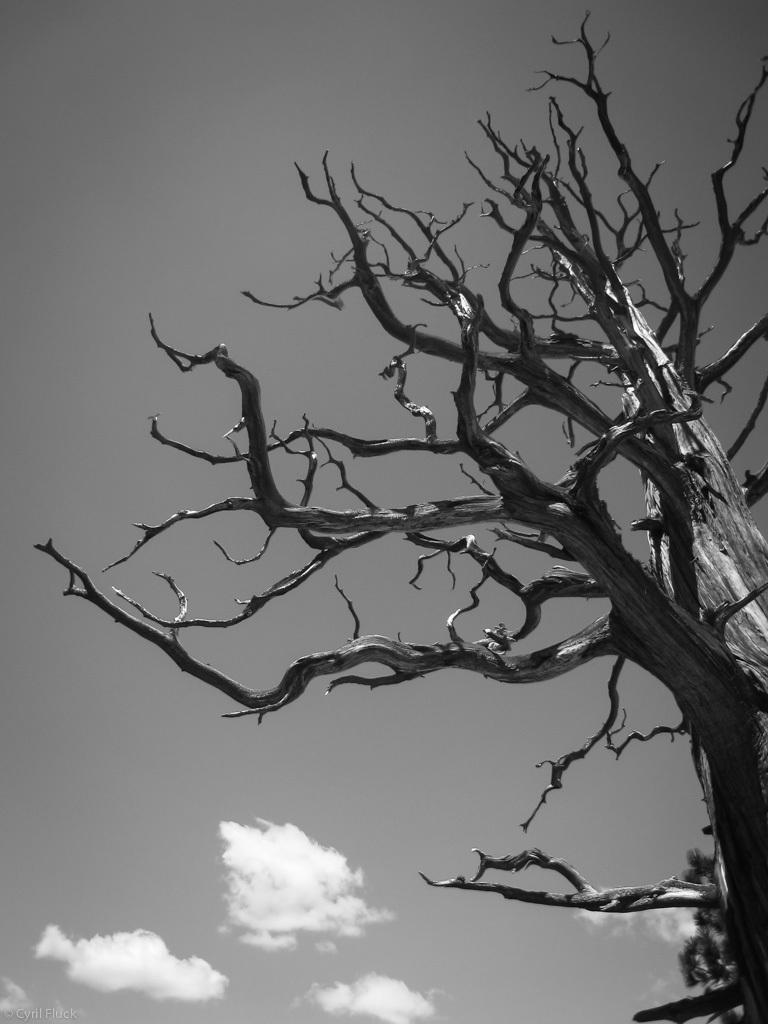What type of natural elements can be seen in the image? There are trees and clouds in the image. What is the color scheme of the image? The image is black and white in color. Where is the carriage located in the image? There is no carriage present in the image. What type of lettuce can be seen growing on the trees in the image? There is no lettuce or indication of plants growing on the trees in the image, as it is a black and white image of trees and clouds. 